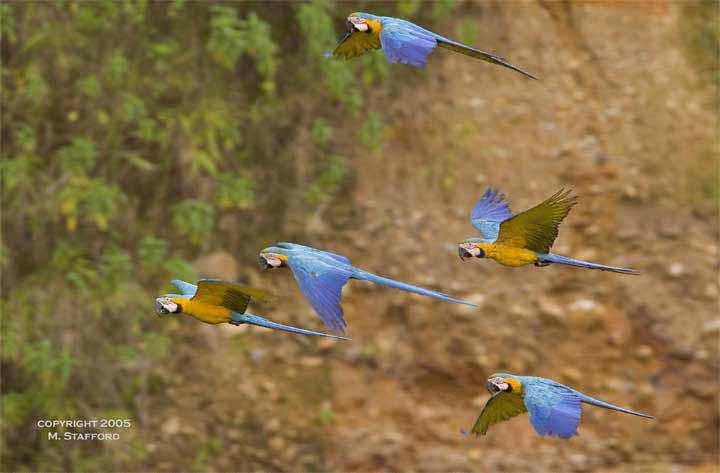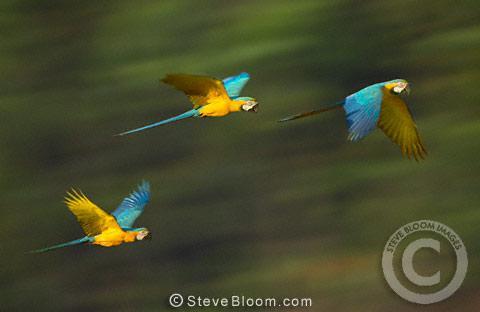The first image is the image on the left, the second image is the image on the right. Assess this claim about the two images: "All birds have yellow and blue coloring and all birds are in flight.". Correct or not? Answer yes or no. Yes. The first image is the image on the left, the second image is the image on the right. Given the left and right images, does the statement "All of the colorful birds are flying in the air." hold true? Answer yes or no. Yes. 